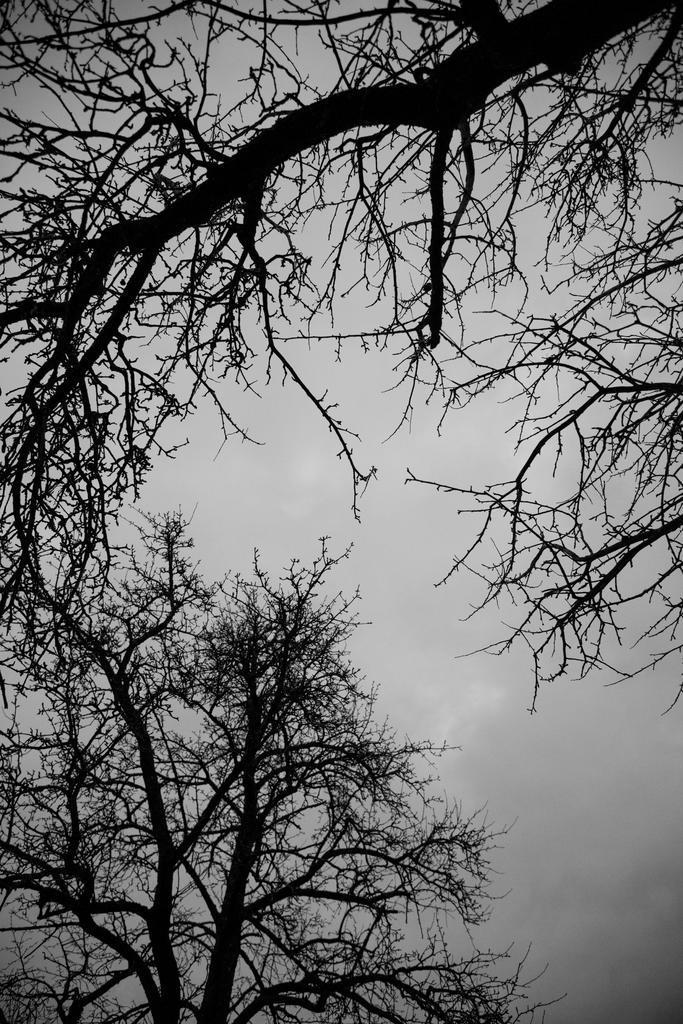In one or two sentences, can you explain what this image depicts? In the picture I can see trees. In the background I can see the sky. 